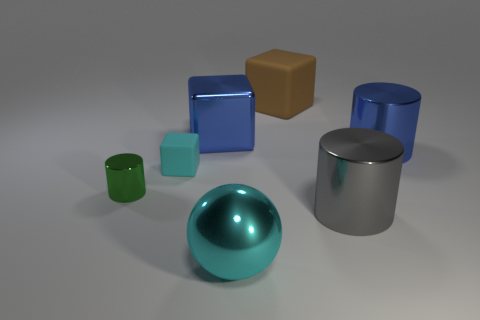What number of other things are there of the same color as the tiny rubber block?
Offer a terse response. 1. What size is the green metal object?
Provide a short and direct response. Small. Are any small blue shiny cylinders visible?
Your answer should be very brief. No. Are there more large brown things to the left of the blue metal cylinder than tiny cyan blocks to the right of the large gray thing?
Offer a terse response. Yes. What is the big object that is on the right side of the cyan ball and on the left side of the large gray metallic cylinder made of?
Make the answer very short. Rubber. Is the shape of the small cyan object the same as the brown matte thing?
Your response must be concise. Yes. There is a big cyan thing; what number of cyan spheres are to the left of it?
Provide a short and direct response. 0. Do the rubber object to the left of the cyan shiny sphere and the cyan metallic sphere have the same size?
Make the answer very short. No. What color is the other small thing that is the same shape as the brown thing?
Offer a very short reply. Cyan. Is there anything else that has the same shape as the large cyan metallic object?
Your answer should be very brief. No. 